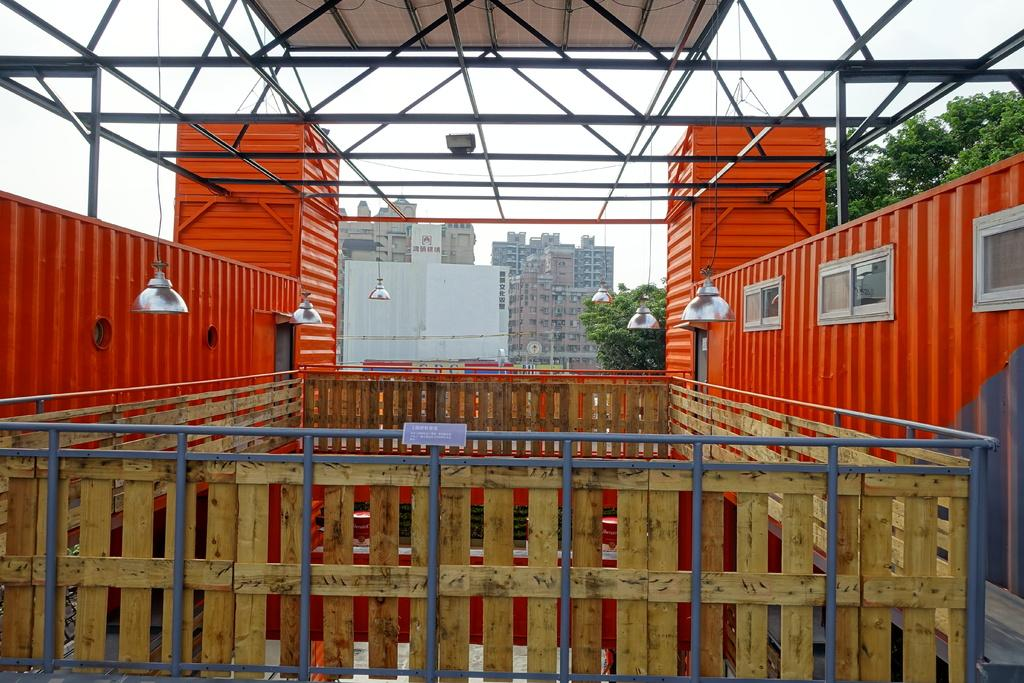What objects can be seen in the image that are made of metal or wood? There are rods, wooden planks, and a board visible in the image. What type of openings can be seen in the image? There are windows in the image. What can be used to provide illumination in the image? There are lights in the image. What type of electrical components can be seen in the image? There are wires in the image. What can be seen in the background of the image? There are buildings, trees, and sky visible in the background of the image. What type of pencil can be seen being used to draw on the board in the image? There is no pencil or drawing activity present in the image. What type of copy machine can be seen in the image? There is no copy machine present in the image. 